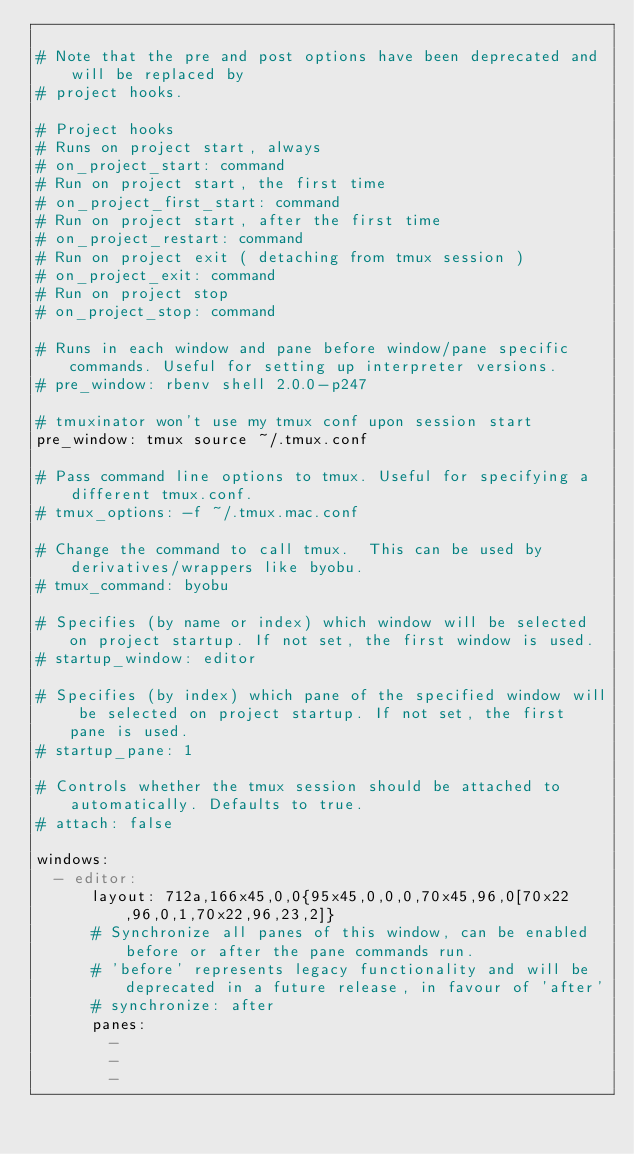<code> <loc_0><loc_0><loc_500><loc_500><_YAML_>
# Note that the pre and post options have been deprecated and will be replaced by
# project hooks.

# Project hooks
# Runs on project start, always
# on_project_start: command
# Run on project start, the first time
# on_project_first_start: command
# Run on project start, after the first time
# on_project_restart: command
# Run on project exit ( detaching from tmux session )
# on_project_exit: command
# Run on project stop
# on_project_stop: command

# Runs in each window and pane before window/pane specific commands. Useful for setting up interpreter versions.
# pre_window: rbenv shell 2.0.0-p247

# tmuxinator won't use my tmux conf upon session start
pre_window: tmux source ~/.tmux.conf

# Pass command line options to tmux. Useful for specifying a different tmux.conf.
# tmux_options: -f ~/.tmux.mac.conf

# Change the command to call tmux.  This can be used by derivatives/wrappers like byobu.
# tmux_command: byobu

# Specifies (by name or index) which window will be selected on project startup. If not set, the first window is used.
# startup_window: editor

# Specifies (by index) which pane of the specified window will be selected on project startup. If not set, the first pane is used.
# startup_pane: 1

# Controls whether the tmux session should be attached to automatically. Defaults to true.
# attach: false

windows:
  - editor:
      layout: 712a,166x45,0,0{95x45,0,0,0,70x45,96,0[70x22,96,0,1,70x22,96,23,2]}
      # Synchronize all panes of this window, can be enabled before or after the pane commands run.
      # 'before' represents legacy functionality and will be deprecated in a future release, in favour of 'after'
      # synchronize: after
      panes:
        - 
        - 
        - 
</code> 